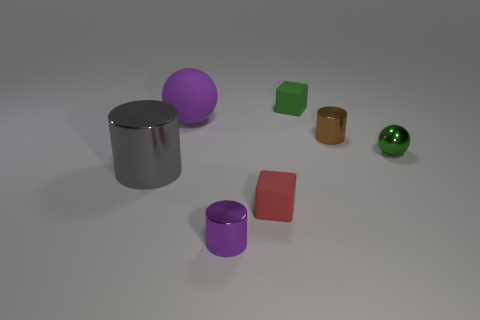Add 1 tiny green objects. How many objects exist? 8 Subtract all cubes. How many objects are left? 5 Subtract 0 brown spheres. How many objects are left? 7 Subtract all big purple matte spheres. Subtract all purple rubber objects. How many objects are left? 5 Add 7 small brown shiny cylinders. How many small brown shiny cylinders are left? 8 Add 2 small cylinders. How many small cylinders exist? 4 